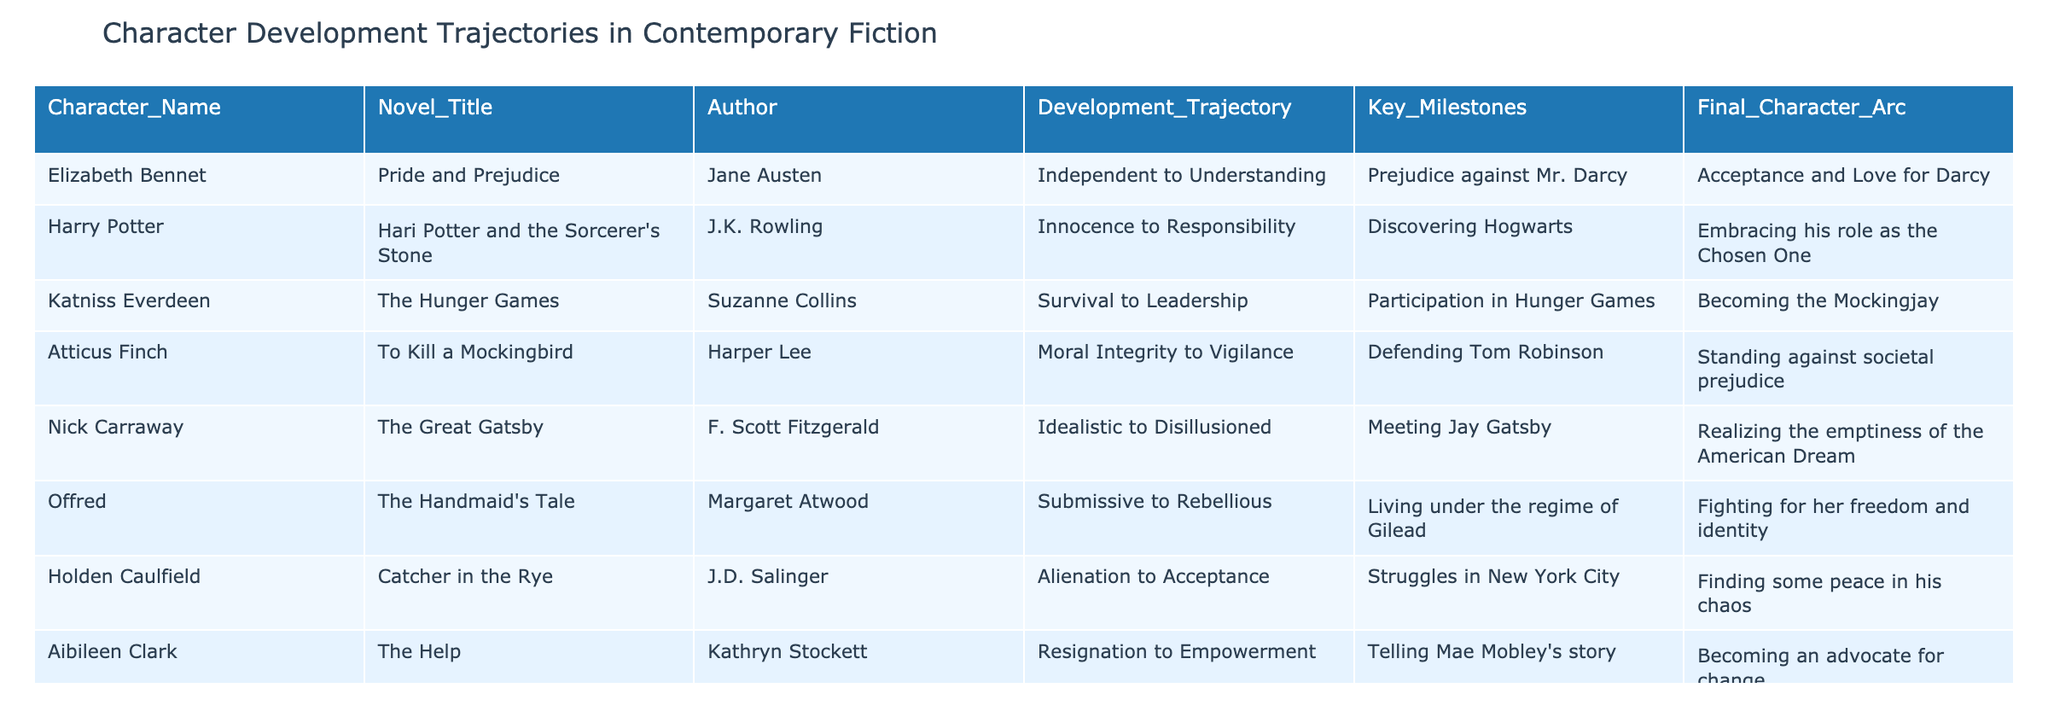What is the development trajectory of Katniss Everdeen? The development trajectory of Katniss Everdeen is from Survival to Leadership, as indicated in the table.
Answer: Survival to Leadership Which author created the character Elizabeth Bennet? The author of Elizabeth Bennet is Jane Austen, as seen in the table's Author column corresponding to her name.
Answer: Jane Austen True or False: Harry Potter's final character arc is about maintaining innocence. The final character arc for Harry Potter is embracing his role as the Chosen One, not about maintaining innocence, making this statement false.
Answer: False What key milestone signifies Offred's transition in her character development? Offred's key milestone is living under the regime of Gilead, which marks her transition from submissive to rebellious, as detailed in the table.
Answer: Living under the regime of Gilead Which character has a trajectory from Idealistic to Disillusioned? The character with this trajectory is Nick Carraway, as shown in the table under the Development_Trajectory column.
Answer: Nick Carraway What is the average number of key milestones across all the characters listed? Counting the key milestones for each character results in 8 unique milestones. Since there are eight characters, the average number of key milestones is 8/8 = 1.
Answer: 1 How many characters have a final character arc involving advocacy or fighting for change? The table lists Aibileen Clark and Offred as characters whose final arcs involve advocacy or fighting for change, which amounts to two characters.
Answer: 2 What character arc evolves from Resignation to Empowerment? Aibileen Clark's character arc evolves from Resignation to Empowerment, as noted in the table under the Final_Character_Arc column.
Answer: Aibileen Clark Which character does not experience a change in societal perspective? Nick Carraway does not experience a change in societal perspective, as his arc reflects disillusionment with the American Dream rather than a shift in personal beliefs.
Answer: Nick Carraway What can be inferred about the overall themes of character development in this table? The overall themes indicate transformations focusing on personal growth, taking on responsibilities, and confronting societal issues, as evidenced by several characters' development trajectories and final arcs.
Answer: Transformations focused on personal growth and societal confrontations 